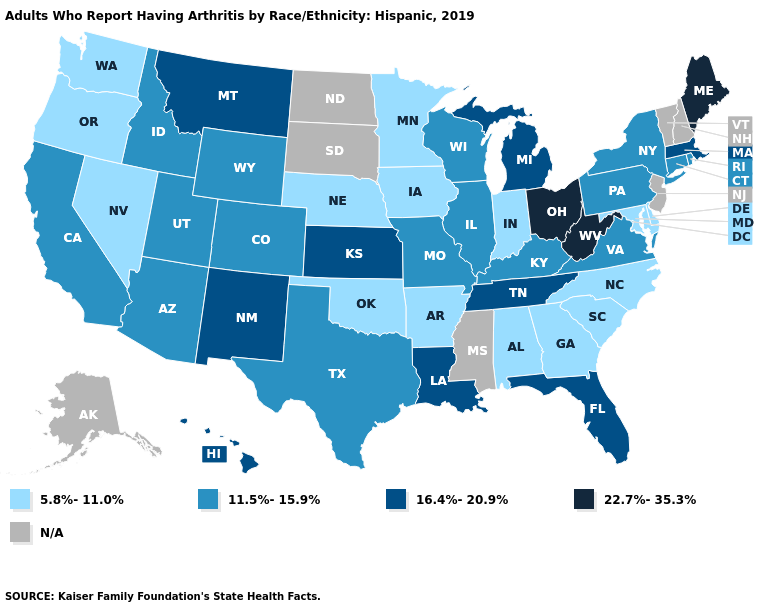Does the map have missing data?
Give a very brief answer. Yes. What is the value of West Virginia?
Give a very brief answer. 22.7%-35.3%. What is the lowest value in the Northeast?
Keep it brief. 11.5%-15.9%. Does Massachusetts have the highest value in the Northeast?
Answer briefly. No. What is the value of New Hampshire?
Answer briefly. N/A. What is the highest value in states that border Minnesota?
Quick response, please. 11.5%-15.9%. How many symbols are there in the legend?
Short answer required. 5. Name the states that have a value in the range N/A?
Concise answer only. Alaska, Mississippi, New Hampshire, New Jersey, North Dakota, South Dakota, Vermont. Name the states that have a value in the range 22.7%-35.3%?
Be succinct. Maine, Ohio, West Virginia. Does the map have missing data?
Keep it brief. Yes. Among the states that border Connecticut , does Rhode Island have the lowest value?
Be succinct. Yes. Does the map have missing data?
Write a very short answer. Yes. Name the states that have a value in the range N/A?
Give a very brief answer. Alaska, Mississippi, New Hampshire, New Jersey, North Dakota, South Dakota, Vermont. 